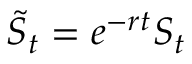<formula> <loc_0><loc_0><loc_500><loc_500>{ \tilde { S } } _ { t } = e ^ { - r t } S _ { t }</formula> 